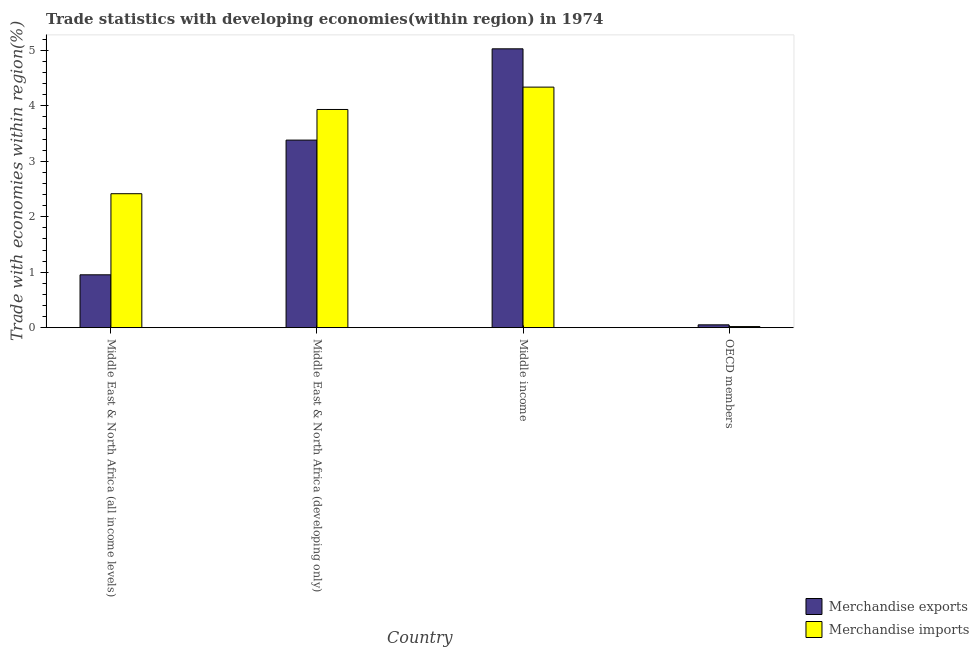How many groups of bars are there?
Make the answer very short. 4. Are the number of bars on each tick of the X-axis equal?
Provide a short and direct response. Yes. How many bars are there on the 1st tick from the right?
Provide a short and direct response. 2. What is the label of the 2nd group of bars from the left?
Keep it short and to the point. Middle East & North Africa (developing only). What is the merchandise imports in Middle income?
Ensure brevity in your answer.  4.34. Across all countries, what is the maximum merchandise imports?
Offer a very short reply. 4.34. Across all countries, what is the minimum merchandise exports?
Keep it short and to the point. 0.05. In which country was the merchandise imports maximum?
Offer a terse response. Middle income. What is the total merchandise exports in the graph?
Provide a succinct answer. 9.42. What is the difference between the merchandise imports in Middle East & North Africa (all income levels) and that in OECD members?
Give a very brief answer. 2.4. What is the difference between the merchandise imports in OECD members and the merchandise exports in Middle income?
Offer a very short reply. -5.01. What is the average merchandise exports per country?
Keep it short and to the point. 2.35. What is the difference between the merchandise exports and merchandise imports in Middle income?
Keep it short and to the point. 0.69. What is the ratio of the merchandise imports in Middle East & North Africa (all income levels) to that in OECD members?
Give a very brief answer. 122.02. Is the difference between the merchandise exports in Middle East & North Africa (developing only) and Middle income greater than the difference between the merchandise imports in Middle East & North Africa (developing only) and Middle income?
Make the answer very short. No. What is the difference between the highest and the second highest merchandise imports?
Provide a succinct answer. 0.4. What is the difference between the highest and the lowest merchandise exports?
Make the answer very short. 4.98. In how many countries, is the merchandise exports greater than the average merchandise exports taken over all countries?
Offer a very short reply. 2. What does the 2nd bar from the left in Middle income represents?
Give a very brief answer. Merchandise imports. What does the 1st bar from the right in Middle East & North Africa (all income levels) represents?
Provide a succinct answer. Merchandise imports. How many bars are there?
Your response must be concise. 8. Does the graph contain any zero values?
Your response must be concise. No. What is the title of the graph?
Your answer should be compact. Trade statistics with developing economies(within region) in 1974. What is the label or title of the X-axis?
Offer a very short reply. Country. What is the label or title of the Y-axis?
Your response must be concise. Trade with economies within region(%). What is the Trade with economies within region(%) in Merchandise exports in Middle East & North Africa (all income levels)?
Ensure brevity in your answer.  0.95. What is the Trade with economies within region(%) of Merchandise imports in Middle East & North Africa (all income levels)?
Offer a terse response. 2.42. What is the Trade with economies within region(%) in Merchandise exports in Middle East & North Africa (developing only)?
Make the answer very short. 3.38. What is the Trade with economies within region(%) of Merchandise imports in Middle East & North Africa (developing only)?
Ensure brevity in your answer.  3.94. What is the Trade with economies within region(%) of Merchandise exports in Middle income?
Provide a succinct answer. 5.03. What is the Trade with economies within region(%) in Merchandise imports in Middle income?
Keep it short and to the point. 4.34. What is the Trade with economies within region(%) in Merchandise exports in OECD members?
Your answer should be compact. 0.05. What is the Trade with economies within region(%) in Merchandise imports in OECD members?
Your response must be concise. 0.02. Across all countries, what is the maximum Trade with economies within region(%) in Merchandise exports?
Provide a succinct answer. 5.03. Across all countries, what is the maximum Trade with economies within region(%) of Merchandise imports?
Keep it short and to the point. 4.34. Across all countries, what is the minimum Trade with economies within region(%) of Merchandise exports?
Offer a terse response. 0.05. Across all countries, what is the minimum Trade with economies within region(%) in Merchandise imports?
Your answer should be compact. 0.02. What is the total Trade with economies within region(%) of Merchandise exports in the graph?
Make the answer very short. 9.42. What is the total Trade with economies within region(%) in Merchandise imports in the graph?
Offer a terse response. 10.71. What is the difference between the Trade with economies within region(%) in Merchandise exports in Middle East & North Africa (all income levels) and that in Middle East & North Africa (developing only)?
Offer a very short reply. -2.43. What is the difference between the Trade with economies within region(%) of Merchandise imports in Middle East & North Africa (all income levels) and that in Middle East & North Africa (developing only)?
Offer a terse response. -1.52. What is the difference between the Trade with economies within region(%) of Merchandise exports in Middle East & North Africa (all income levels) and that in Middle income?
Ensure brevity in your answer.  -4.08. What is the difference between the Trade with economies within region(%) in Merchandise imports in Middle East & North Africa (all income levels) and that in Middle income?
Offer a very short reply. -1.92. What is the difference between the Trade with economies within region(%) of Merchandise exports in Middle East & North Africa (all income levels) and that in OECD members?
Your response must be concise. 0.9. What is the difference between the Trade with economies within region(%) of Merchandise imports in Middle East & North Africa (all income levels) and that in OECD members?
Provide a short and direct response. 2.4. What is the difference between the Trade with economies within region(%) in Merchandise exports in Middle East & North Africa (developing only) and that in Middle income?
Give a very brief answer. -1.65. What is the difference between the Trade with economies within region(%) of Merchandise imports in Middle East & North Africa (developing only) and that in Middle income?
Provide a short and direct response. -0.4. What is the difference between the Trade with economies within region(%) of Merchandise exports in Middle East & North Africa (developing only) and that in OECD members?
Offer a terse response. 3.33. What is the difference between the Trade with economies within region(%) of Merchandise imports in Middle East & North Africa (developing only) and that in OECD members?
Offer a very short reply. 3.92. What is the difference between the Trade with economies within region(%) of Merchandise exports in Middle income and that in OECD members?
Give a very brief answer. 4.98. What is the difference between the Trade with economies within region(%) of Merchandise imports in Middle income and that in OECD members?
Ensure brevity in your answer.  4.32. What is the difference between the Trade with economies within region(%) of Merchandise exports in Middle East & North Africa (all income levels) and the Trade with economies within region(%) of Merchandise imports in Middle East & North Africa (developing only)?
Give a very brief answer. -2.98. What is the difference between the Trade with economies within region(%) of Merchandise exports in Middle East & North Africa (all income levels) and the Trade with economies within region(%) of Merchandise imports in Middle income?
Provide a succinct answer. -3.39. What is the difference between the Trade with economies within region(%) of Merchandise exports in Middle East & North Africa (all income levels) and the Trade with economies within region(%) of Merchandise imports in OECD members?
Keep it short and to the point. 0.93. What is the difference between the Trade with economies within region(%) of Merchandise exports in Middle East & North Africa (developing only) and the Trade with economies within region(%) of Merchandise imports in Middle income?
Ensure brevity in your answer.  -0.96. What is the difference between the Trade with economies within region(%) in Merchandise exports in Middle East & North Africa (developing only) and the Trade with economies within region(%) in Merchandise imports in OECD members?
Give a very brief answer. 3.36. What is the difference between the Trade with economies within region(%) in Merchandise exports in Middle income and the Trade with economies within region(%) in Merchandise imports in OECD members?
Provide a succinct answer. 5.01. What is the average Trade with economies within region(%) in Merchandise exports per country?
Ensure brevity in your answer.  2.35. What is the average Trade with economies within region(%) in Merchandise imports per country?
Give a very brief answer. 2.68. What is the difference between the Trade with economies within region(%) in Merchandise exports and Trade with economies within region(%) in Merchandise imports in Middle East & North Africa (all income levels)?
Offer a very short reply. -1.46. What is the difference between the Trade with economies within region(%) of Merchandise exports and Trade with economies within region(%) of Merchandise imports in Middle East & North Africa (developing only)?
Keep it short and to the point. -0.55. What is the difference between the Trade with economies within region(%) in Merchandise exports and Trade with economies within region(%) in Merchandise imports in Middle income?
Keep it short and to the point. 0.69. What is the difference between the Trade with economies within region(%) in Merchandise exports and Trade with economies within region(%) in Merchandise imports in OECD members?
Keep it short and to the point. 0.03. What is the ratio of the Trade with economies within region(%) of Merchandise exports in Middle East & North Africa (all income levels) to that in Middle East & North Africa (developing only)?
Your response must be concise. 0.28. What is the ratio of the Trade with economies within region(%) of Merchandise imports in Middle East & North Africa (all income levels) to that in Middle East & North Africa (developing only)?
Ensure brevity in your answer.  0.61. What is the ratio of the Trade with economies within region(%) in Merchandise exports in Middle East & North Africa (all income levels) to that in Middle income?
Give a very brief answer. 0.19. What is the ratio of the Trade with economies within region(%) of Merchandise imports in Middle East & North Africa (all income levels) to that in Middle income?
Your answer should be very brief. 0.56. What is the ratio of the Trade with economies within region(%) in Merchandise exports in Middle East & North Africa (all income levels) to that in OECD members?
Provide a short and direct response. 18.7. What is the ratio of the Trade with economies within region(%) of Merchandise imports in Middle East & North Africa (all income levels) to that in OECD members?
Keep it short and to the point. 122.02. What is the ratio of the Trade with economies within region(%) of Merchandise exports in Middle East & North Africa (developing only) to that in Middle income?
Keep it short and to the point. 0.67. What is the ratio of the Trade with economies within region(%) in Merchandise imports in Middle East & North Africa (developing only) to that in Middle income?
Your answer should be very brief. 0.91. What is the ratio of the Trade with economies within region(%) of Merchandise exports in Middle East & North Africa (developing only) to that in OECD members?
Make the answer very short. 66.36. What is the ratio of the Trade with economies within region(%) in Merchandise imports in Middle East & North Africa (developing only) to that in OECD members?
Provide a succinct answer. 198.73. What is the ratio of the Trade with economies within region(%) of Merchandise exports in Middle income to that in OECD members?
Your answer should be very brief. 98.66. What is the ratio of the Trade with economies within region(%) in Merchandise imports in Middle income to that in OECD members?
Provide a succinct answer. 219.11. What is the difference between the highest and the second highest Trade with economies within region(%) of Merchandise exports?
Your answer should be compact. 1.65. What is the difference between the highest and the second highest Trade with economies within region(%) in Merchandise imports?
Give a very brief answer. 0.4. What is the difference between the highest and the lowest Trade with economies within region(%) of Merchandise exports?
Your answer should be compact. 4.98. What is the difference between the highest and the lowest Trade with economies within region(%) in Merchandise imports?
Your response must be concise. 4.32. 